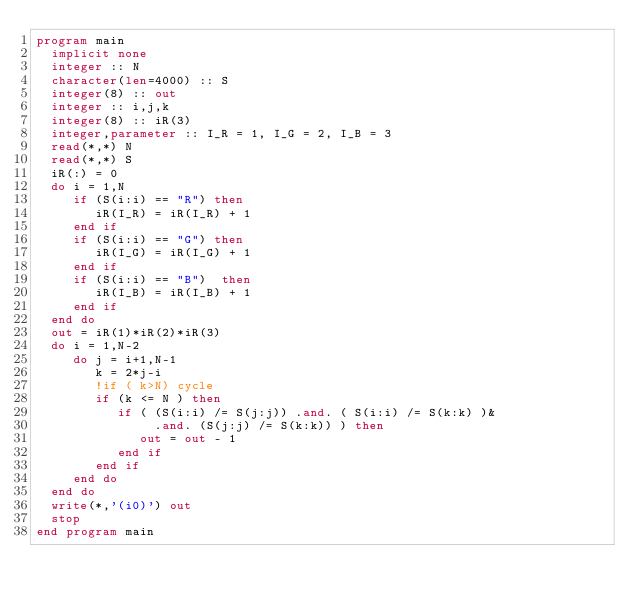Convert code to text. <code><loc_0><loc_0><loc_500><loc_500><_FORTRAN_>program main
  implicit none
  integer :: N
  character(len=4000) :: S
  integer(8) :: out
  integer :: i,j,k
  integer(8) :: iR(3)
  integer,parameter :: I_R = 1, I_G = 2, I_B = 3
  read(*,*) N
  read(*,*) S
  iR(:) = 0
  do i = 1,N
     if (S(i:i) == "R") then
        iR(I_R) = iR(I_R) + 1
     end if 
     if (S(i:i) == "G") then
        iR(I_G) = iR(I_G) + 1
     end if
     if (S(i:i) == "B")  then
        iR(I_B) = iR(I_B) + 1
     end if
  end do
  out = iR(1)*iR(2)*iR(3)
  do i = 1,N-2
     do j = i+1,N-1
        k = 2*j-i
        !if ( k>N) cycle
        if (k <= N ) then
           if ( (S(i:i) /= S(j:j)) .and. ( S(i:i) /= S(k:k) )&
                .and. (S(j:j) /= S(k:k)) ) then
              out = out - 1
           end if
        end if
     end do
  end do
  write(*,'(i0)') out
  stop
end program main
</code> 